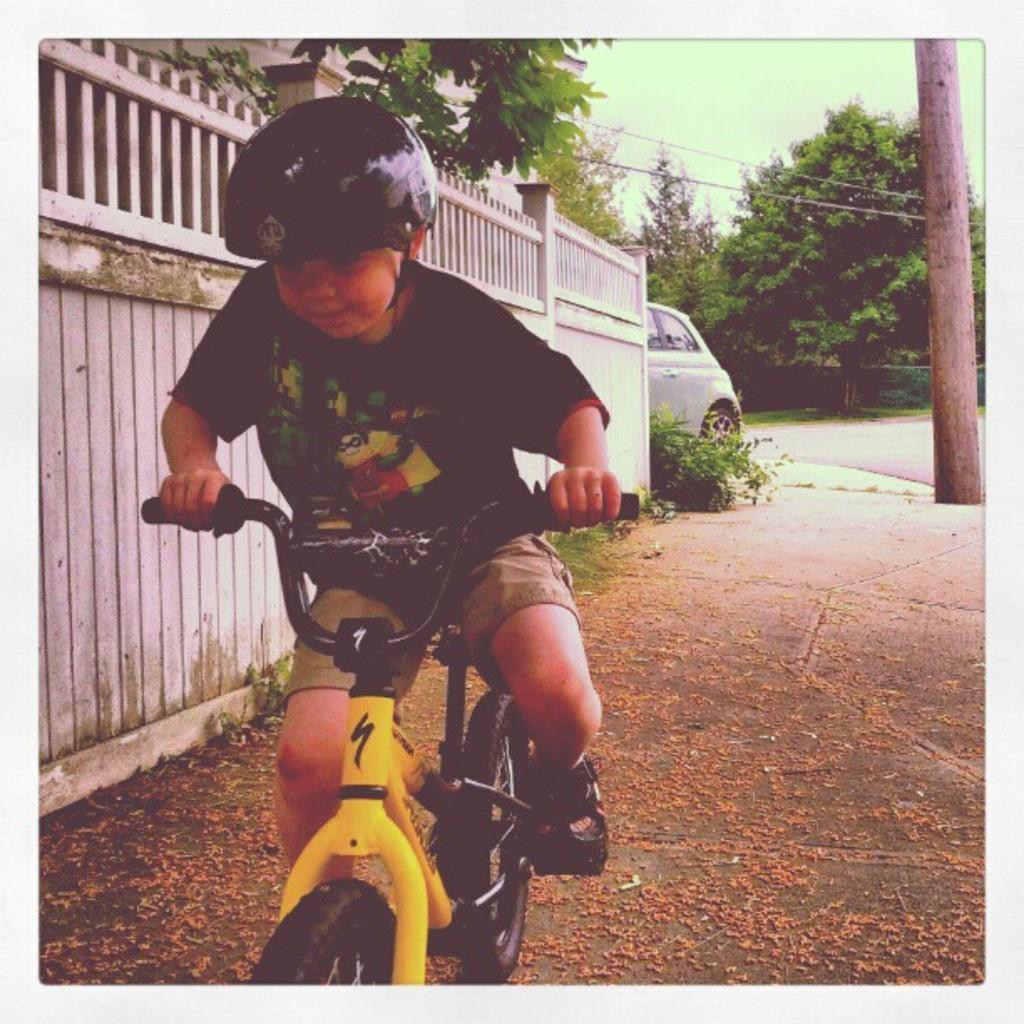In one or two sentences, can you explain what this image depicts? In this picture we can see a boy riding bicycle wore black color T-Shirt, helmet and in the background we can see fence, car, trees, road, wire,sky. 